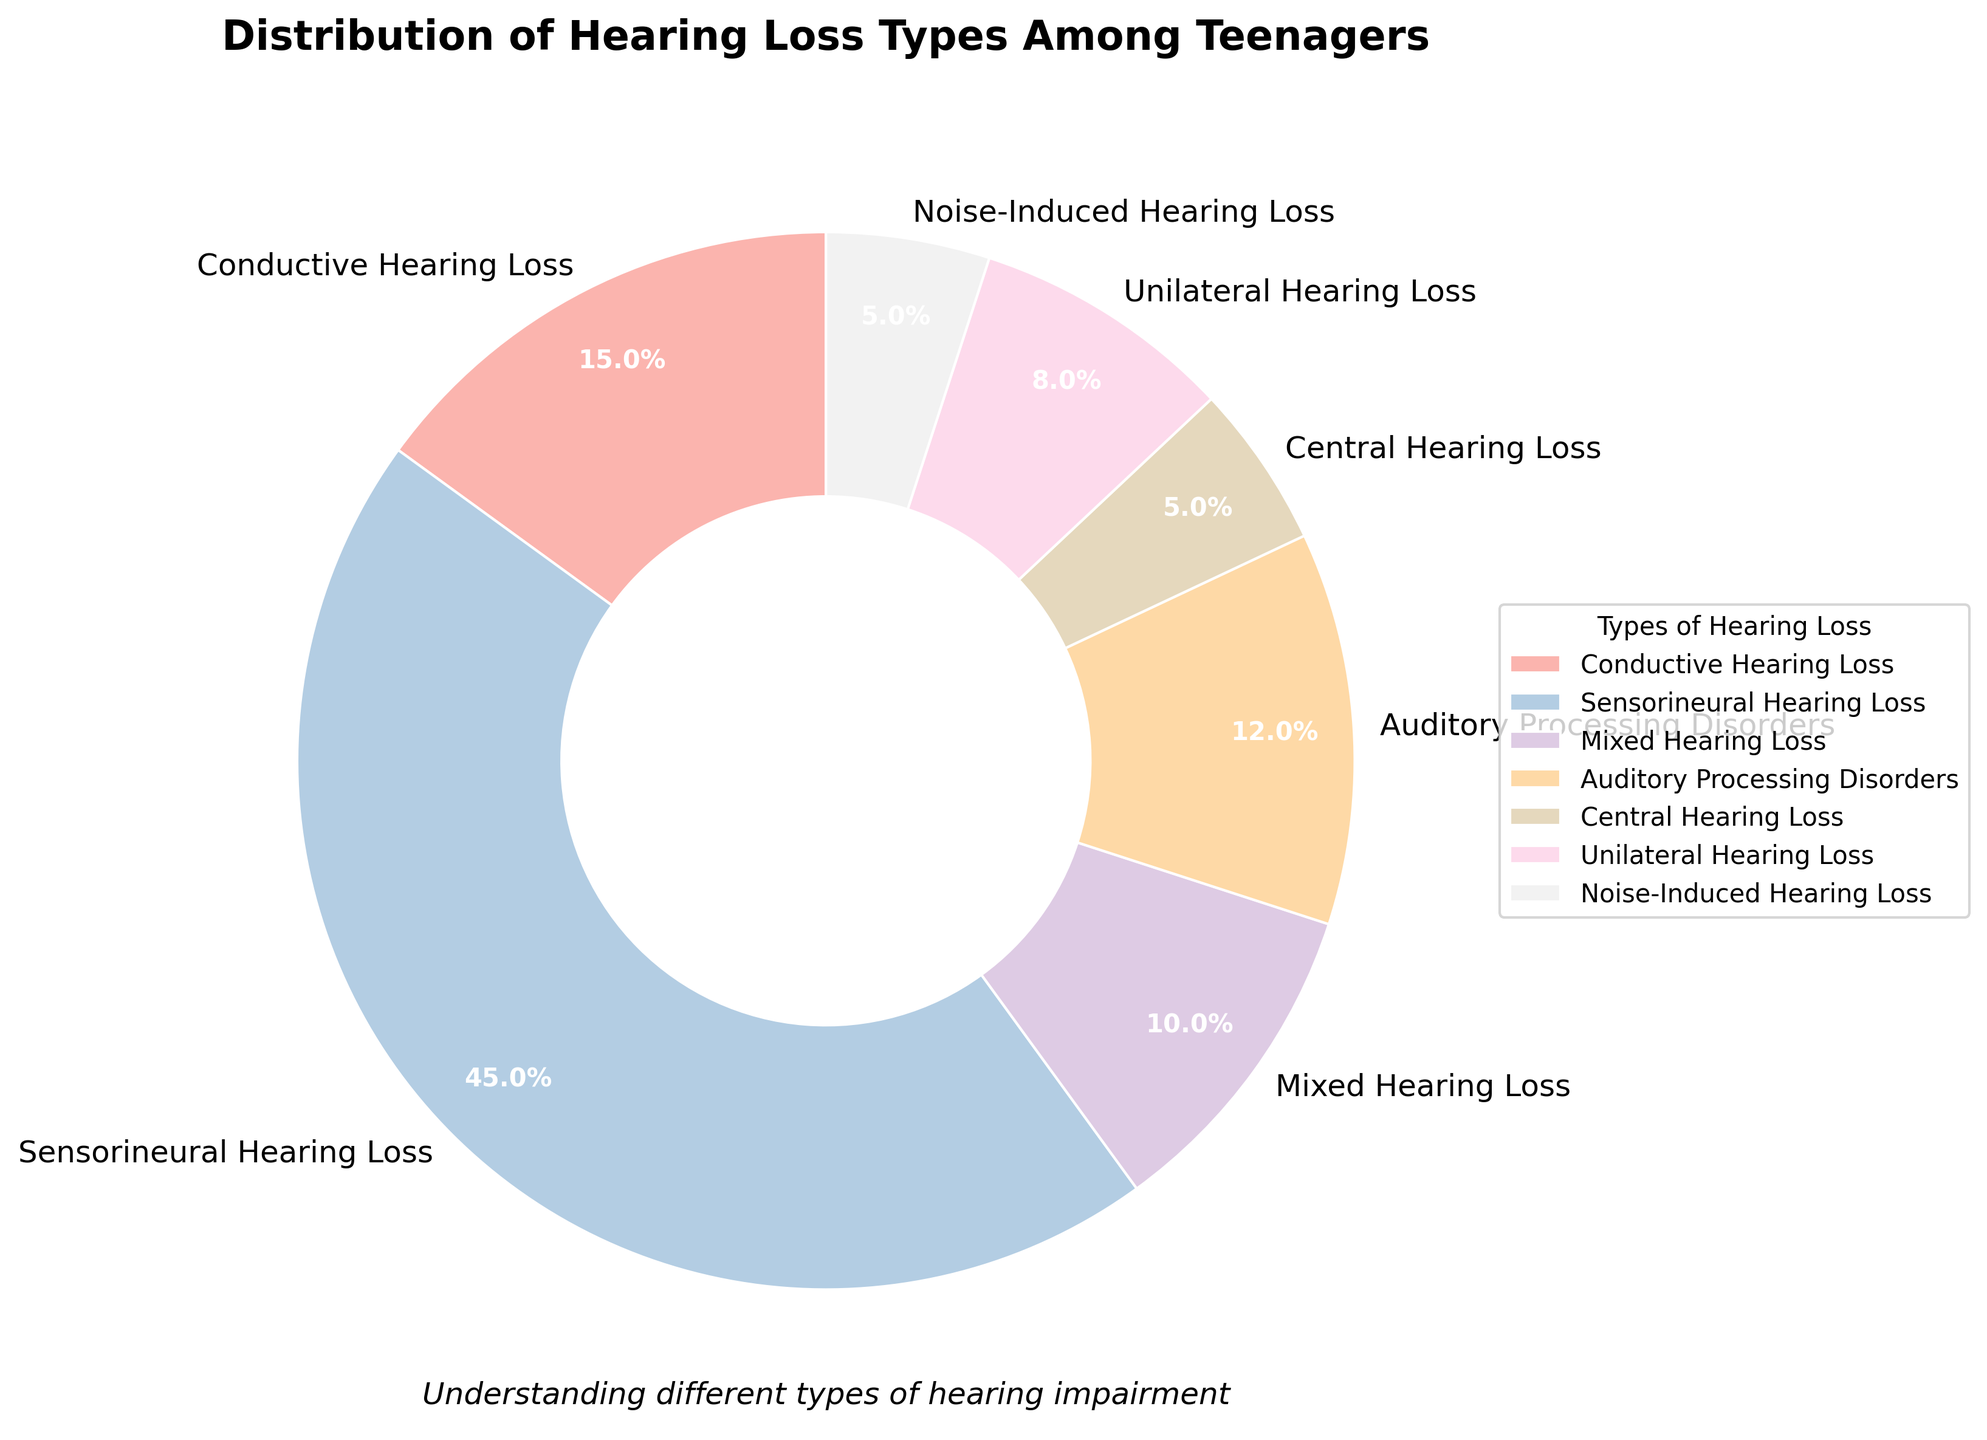What percentage of teenagers have noise-induced hearing loss? Noise-Induced Hearing Loss accounts for 5% of the total as indicated in the pie chart.
Answer: 5% Which type of hearing loss has the highest percentage? Sensorineural Hearing Loss has the highest percentage in the chart at 45%, easily identified as the largest section.
Answer: Sensorineural Hearing Loss How many types of hearing loss together account for less than 10% each? The types of hearing loss that each account for less than 10% are Mixed Hearing Loss (10%), Central Hearing Loss (5%), Unilateral Hearing Loss (8%), and Noise-Induced Hearing Loss (5%). There are 4 types in total.
Answer: 4 types What is the combined percentage of Conductive and Sensorineural Hearing Loss? Conductive Hearing Loss is 15% and Sensorineural Hearing Loss is 45%. Combined, this equals 15% + 45% = 60%.
Answer: 60% Which types of hearing loss together make up more than half of the entire chart? Sensorineural Hearing Loss (45%) and Conductive Hearing Loss (15%) together make up 45% + 15% = 60%, which is more than half.
Answer: Sensorineural and Conductive What type of hearing loss has the fourth largest percentage? To find the fourth largest percentage, we rank from largest to smallest: Sensorineural Hearing Loss (45%), Conductive Hearing Loss (15%), Auditory Processing Disorders (12%), then Unilateral Hearing Loss (8%). Thus, Unilateral Hearing Loss is the fourth largest.
Answer: Unilateral Hearing Loss Which types of hearing loss are represented by colors from the Pastel1 palette? All the types of hearing loss in the pie chart are represented by colors from the Pastel1 palette as specified by the given plotting guidelines.
Answer: All types Are there more teenagers with Central Hearing Loss or Noise-Induced Hearing Loss? According to the pie chart, Central Hearing Loss and Noise-Induced Hearing Loss both account for 5% each, so the number of teenagers is equal for these two types.
Answer: Equal Which section is the smallest in the pie chart? The sections for Central Hearing Loss and Noise-Induced Hearing Loss are both the smallest at 5%.
Answer: Central and Noise-Induced 